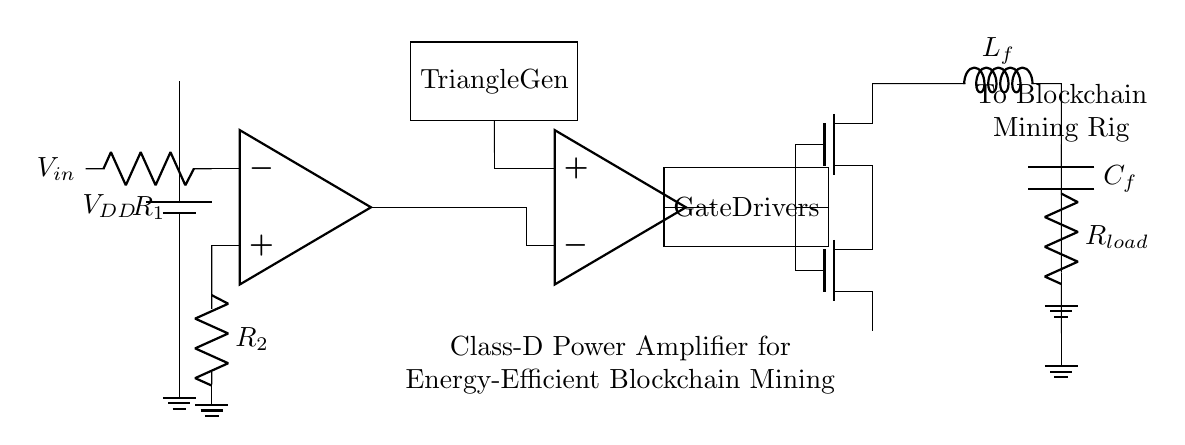What is the type of this amplifier? The circuit diagram indicates that this is a Class-D power amplifier, classified by its switching mechanism and efficiency in handling power.
Answer: Class-D What components are present in the input stage? The input stage contains an operational amplifier and two resistors labeled R1 and R2. R1 connects to the input voltage, while R2 is connected to ground.
Answer: Operational amplifier, R1, R2 What is the function of the triangular wave generator? The triangular wave generator produces a triangular waveform that serves as a reference signal for the comparator in the circuit, helping to modulate the signal for amplification.
Answer: Modulation reference What does the output stage consist of? The output stage comprises two n-channel MOSFETs connected to a load resistor, allowing for efficient power amplification through switching.
Answer: Two MOSFETs and a load resistor How does the amplifier achieve energy efficiency? The amplifier uses a Class-D configuration which employs pulse width modulation to minimize power losses, resulting in higher efficiency compared to linear amplifiers.
Answer: Pulse width modulation What is the role of the gate drivers in this circuit? The gate drivers control the switching of the MOSFETs based on the output from the comparator, ensuring proper timing and efficient signal amplification.
Answer: Control MOSFET switching 